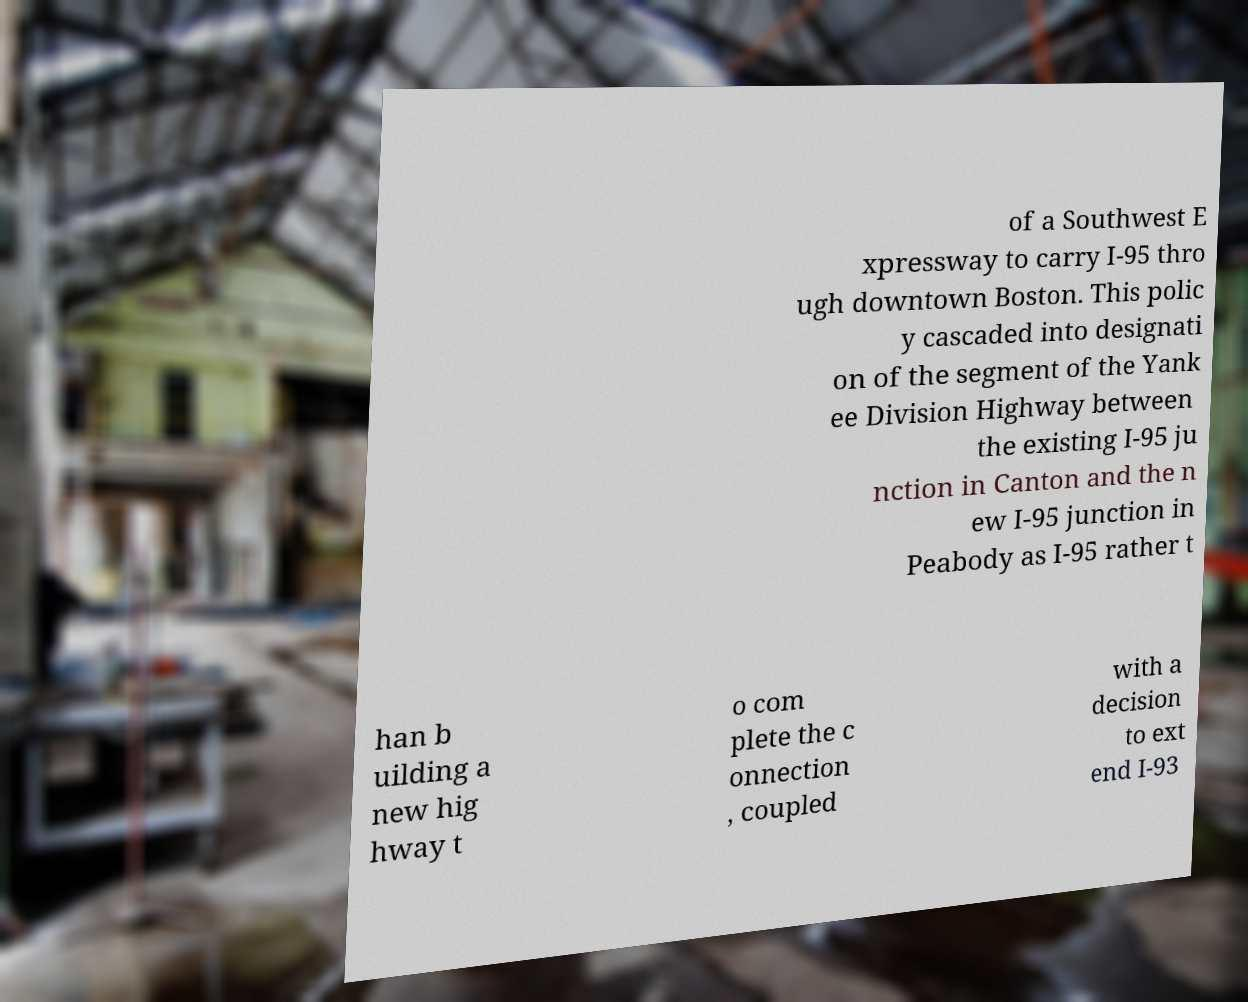Please identify and transcribe the text found in this image. of a Southwest E xpressway to carry I-95 thro ugh downtown Boston. This polic y cascaded into designati on of the segment of the Yank ee Division Highway between the existing I-95 ju nction in Canton and the n ew I-95 junction in Peabody as I-95 rather t han b uilding a new hig hway t o com plete the c onnection , coupled with a decision to ext end I-93 